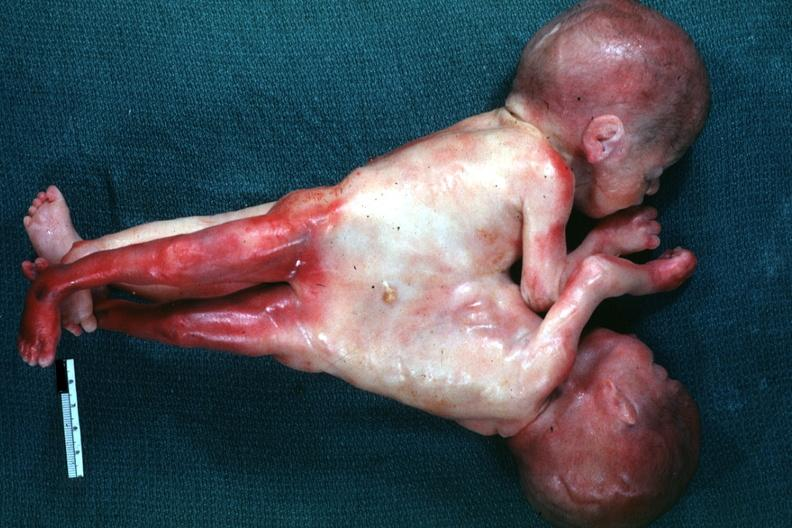what joined at chest and abdomen?
Answer the question using a single word or phrase. Lateral view 